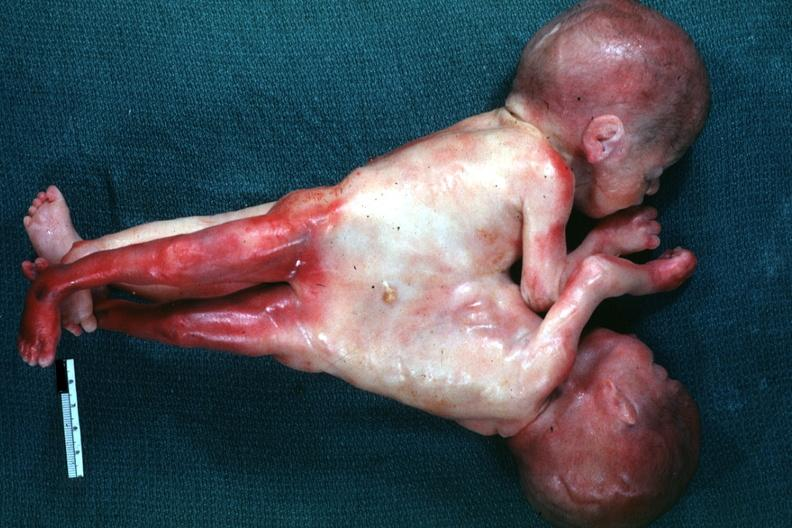what joined at chest and abdomen?
Answer the question using a single word or phrase. Lateral view 